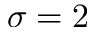<formula> <loc_0><loc_0><loc_500><loc_500>\sigma = 2</formula> 